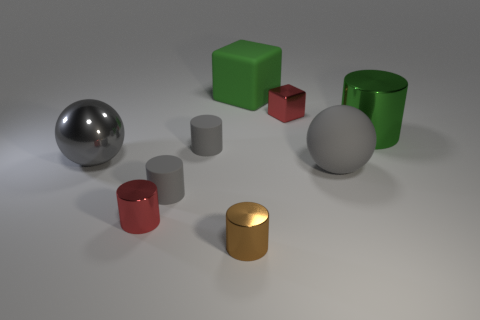Are there the same number of red things that are to the left of the tiny red metallic cylinder and metal cylinders to the right of the large green matte block?
Your response must be concise. No. There is a gray thing that is on the right side of the big green rubber cube; what is it made of?
Keep it short and to the point. Rubber. Is the number of tiny gray objects less than the number of gray matte balls?
Provide a short and direct response. No. What shape is the large object that is both in front of the small metallic block and left of the small red metallic cube?
Provide a short and direct response. Sphere. What number of big red rubber things are there?
Your response must be concise. 0. What is the material of the small gray thing that is behind the big sphere on the right side of the matte object that is behind the small red metal cube?
Your response must be concise. Rubber. There is a tiny red metallic object that is in front of the green metal cylinder; what number of gray shiny objects are in front of it?
Offer a terse response. 0. There is a large rubber thing that is the same shape as the large gray metal thing; what is its color?
Give a very brief answer. Gray. Does the red block have the same material as the small brown cylinder?
Offer a terse response. Yes. How many cylinders are small red shiny objects or large green shiny things?
Make the answer very short. 2. 